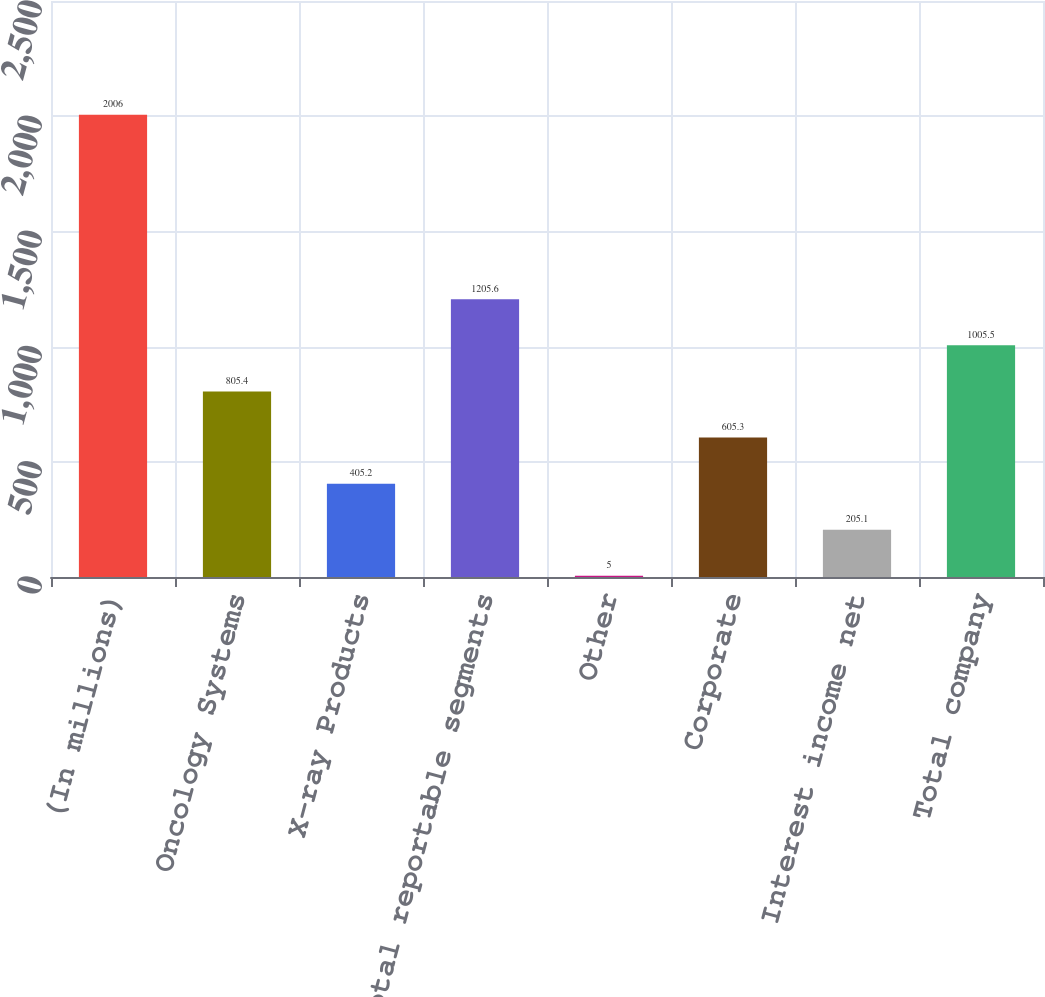Convert chart to OTSL. <chart><loc_0><loc_0><loc_500><loc_500><bar_chart><fcel>(In millions)<fcel>Oncology Systems<fcel>X-ray Products<fcel>Total reportable segments<fcel>Other<fcel>Corporate<fcel>Interest income net<fcel>Total company<nl><fcel>2006<fcel>805.4<fcel>405.2<fcel>1205.6<fcel>5<fcel>605.3<fcel>205.1<fcel>1005.5<nl></chart> 